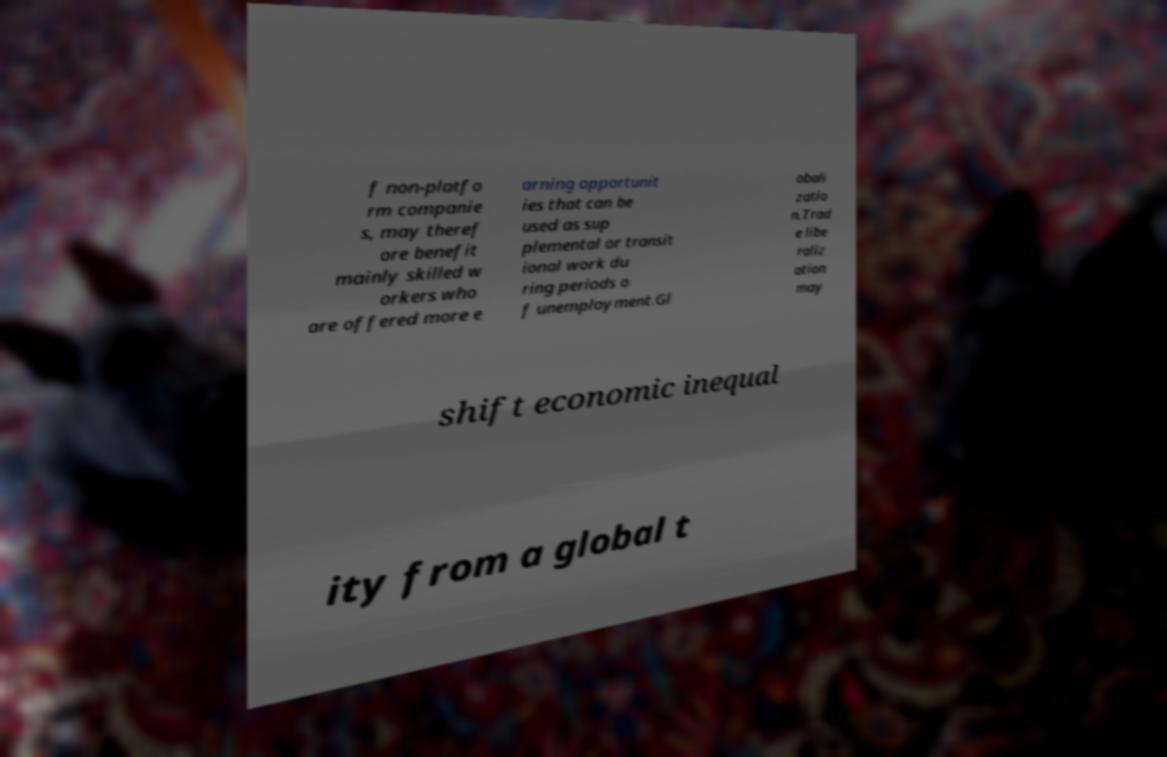What themes could this fragment of text be related to based on the words you can see? The visible fragment of text seems to relate to themes of labor economics, the impact of globalization on employment, and the dynamics between various forms of work and economic inequality. It suggests a focus on how different sectors and types of labor, such as those within non-platform companies, interact with broader economic forces like globalization and trade liberalization. 